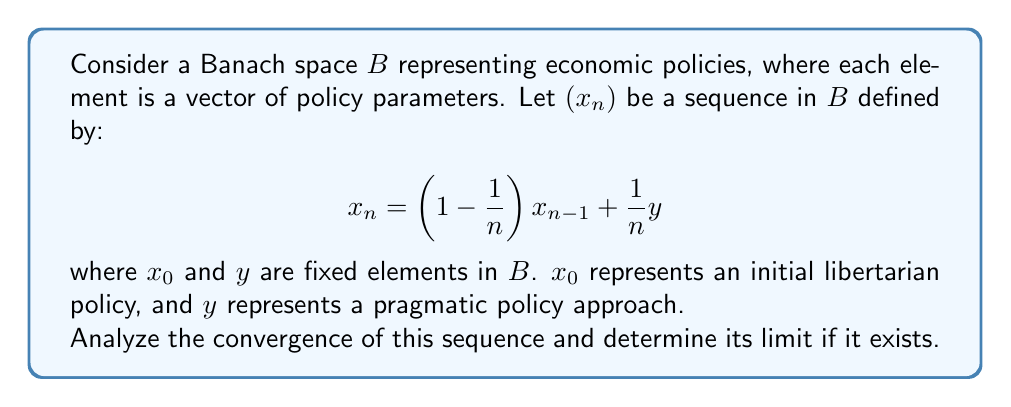Help me with this question. Let's approach this step-by-step:

1) First, we need to recognize that this is a recursive sequence in a Banach space. The recursion formula gradually shifts the policy from the initial libertarian approach towards a more pragmatic one.

2) To analyze convergence, we can use the Banach Fixed Point Theorem. Let's define an operator $T: B \to B$ as:

   $$T(x) = \left(1 - \frac{1}{n}\right)x + \frac{1}{n}y$$

3) We need to show that $T$ is a contraction mapping for large $n$. For any $x, z \in B$:

   $$\|T(x) - T(z)\| = \left\|\left(1 - \frac{1}{n}\right)(x-z)\right\| = \left(1 - \frac{1}{n}\right)\|x-z\|$$

4) For $n > 1$, we have $0 < 1 - \frac{1}{n} < 1$, so $T$ is indeed a contraction mapping.

5) By the Banach Fixed Point Theorem, $T$ has a unique fixed point, which is the limit of our sequence.

6) To find this fixed point, let $x^*$ be the limit. Then:

   $$x^* = \left(1 - \frac{1}{n}\right)x^* + \frac{1}{n}y$$

7) Solving for $x^*$:

   $$x^* = y$$

8) Therefore, the sequence converges to $y$, which represents the pragmatic policy approach.

9) This convergence reflects a gradual shift from the initial libertarian policy $x_0$ to the pragmatic policy $y$, aligning with the persona's pragmatic challenge to libertarian ideals.
Answer: The sequence converges to $y$. 